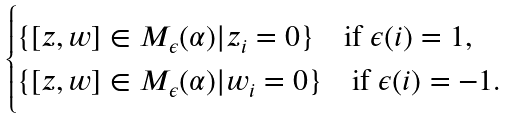<formula> <loc_0><loc_0><loc_500><loc_500>\begin{cases} \{ [ z , w ] \in M _ { \epsilon } ( \alpha ) | z _ { i } = 0 \} \quad \text {if $\epsilon (i)=1$,} \\ \{ [ z , w ] \in M _ { \epsilon } ( \alpha ) | w _ { i } = 0 \} \quad \text {if $\epsilon (i)=-1$.} \end{cases}</formula> 